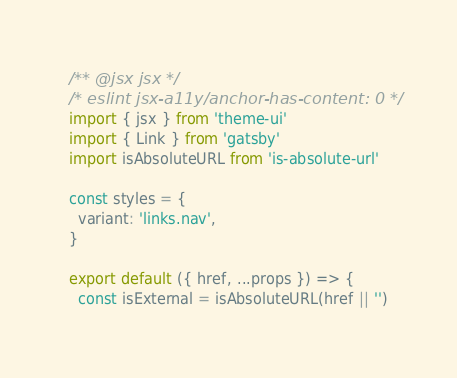Convert code to text. <code><loc_0><loc_0><loc_500><loc_500><_JavaScript_>/** @jsx jsx */
/* eslint jsx-a11y/anchor-has-content: 0 */
import { jsx } from 'theme-ui'
import { Link } from 'gatsby'
import isAbsoluteURL from 'is-absolute-url'

const styles = {
  variant: 'links.nav',
}

export default ({ href, ...props }) => {
  const isExternal = isAbsoluteURL(href || '')</code> 